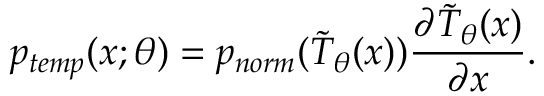<formula> <loc_0><loc_0><loc_500><loc_500>p _ { t e m p } ( x ; \theta ) = p _ { n o r m } ( \tilde { T } _ { \theta } ( x ) ) \frac { \partial \tilde { T } _ { \theta } ( x ) } { \partial x } .</formula> 